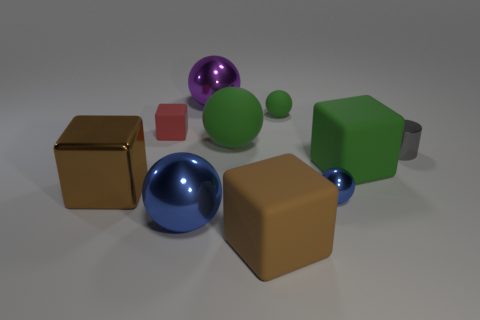Subtract all green balls. How many were subtracted if there are1green balls left? 1 Subtract all yellow cylinders. How many brown blocks are left? 2 Subtract all green blocks. How many blocks are left? 3 Subtract all green cubes. How many cubes are left? 3 Subtract 2 blocks. How many blocks are left? 2 Subtract all cylinders. How many objects are left? 9 Subtract all cyan cubes. Subtract all green cylinders. How many cubes are left? 4 Add 6 blue shiny things. How many blue shiny things are left? 8 Add 5 matte cubes. How many matte cubes exist? 8 Subtract 0 gray balls. How many objects are left? 10 